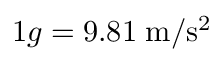<formula> <loc_0><loc_0><loc_500><loc_500>1 g = 9 . 8 1 \, m / s ^ { 2 }</formula> 